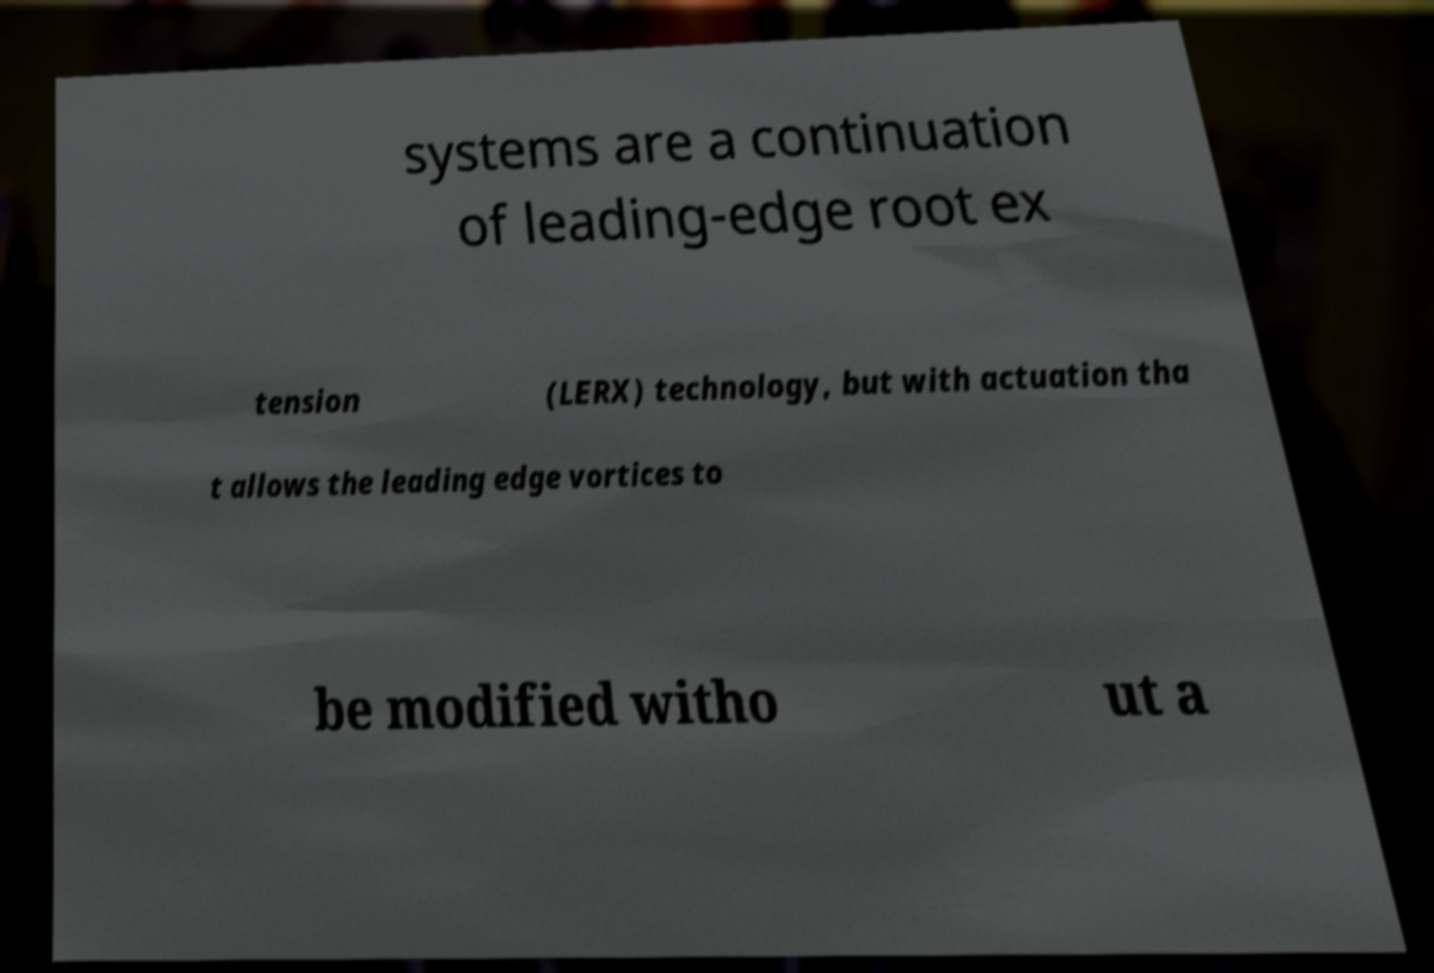I need the written content from this picture converted into text. Can you do that? systems are a continuation of leading-edge root ex tension (LERX) technology, but with actuation tha t allows the leading edge vortices to be modified witho ut a 